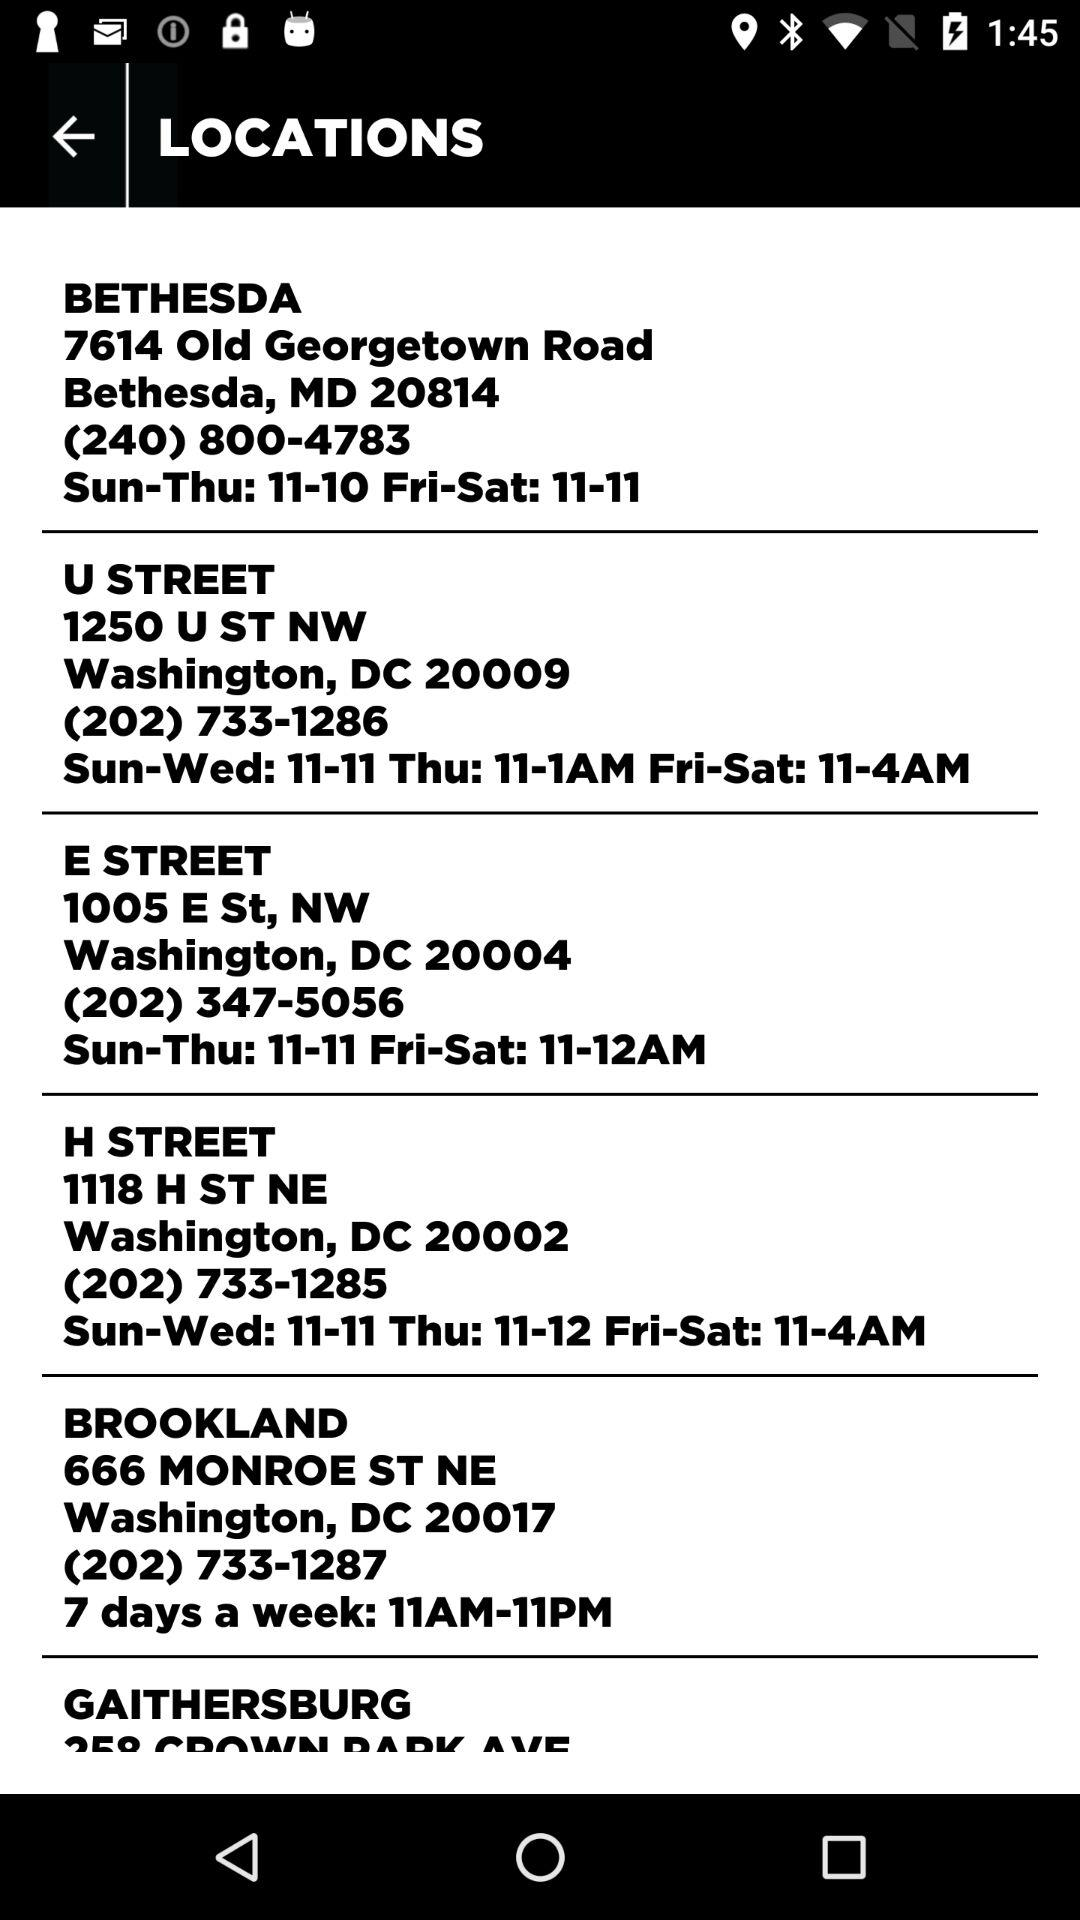What is the contact number for "E STREET"? The contact number is (202) 347-5056. 